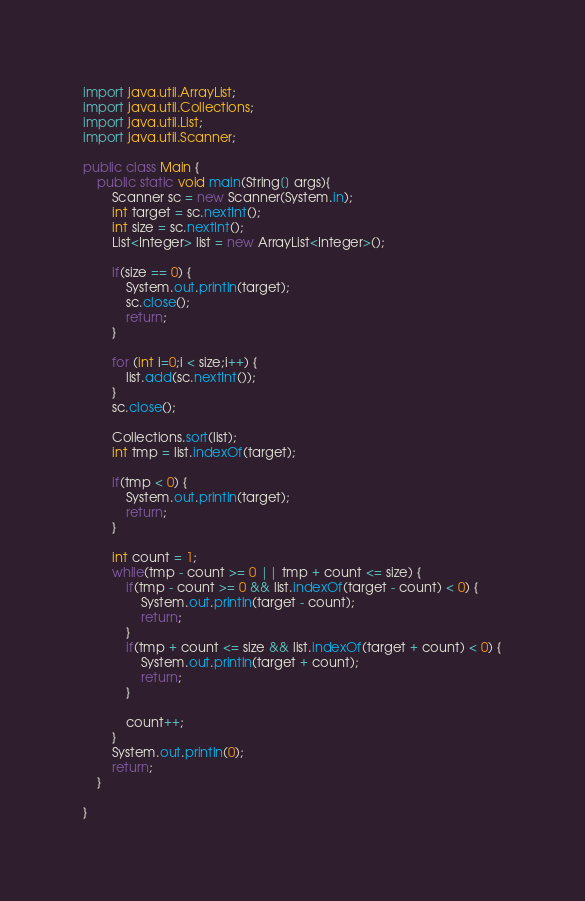<code> <loc_0><loc_0><loc_500><loc_500><_Java_>import java.util.ArrayList;
import java.util.Collections;
import java.util.List;
import java.util.Scanner;

public class Main {
	public static void main(String[] args){
		Scanner sc = new Scanner(System.in);
		int target = sc.nextInt();
		int size = sc.nextInt();
		List<Integer> list = new ArrayList<Integer>();

		if(size == 0) {
			System.out.println(target);
			sc.close();
			return;
		}

		for (int i=0;i < size;i++) {
			list.add(sc.nextInt());
		}
		sc.close();

		Collections.sort(list);
		int tmp = list.indexOf(target);

		if(tmp < 0) {
			System.out.println(target);
			return;
		}

		int count = 1;
		while(tmp - count >= 0 || tmp + count <= size) {
			if(tmp - count >= 0 && list.indexOf(target - count) < 0) {
				System.out.println(target - count);
				return;
			}
			if(tmp + count <= size && list.indexOf(target + count) < 0) {
				System.out.println(target + count);
				return;
			}

			count++;
		}
		System.out.println(0);
		return;
	}

}</code> 